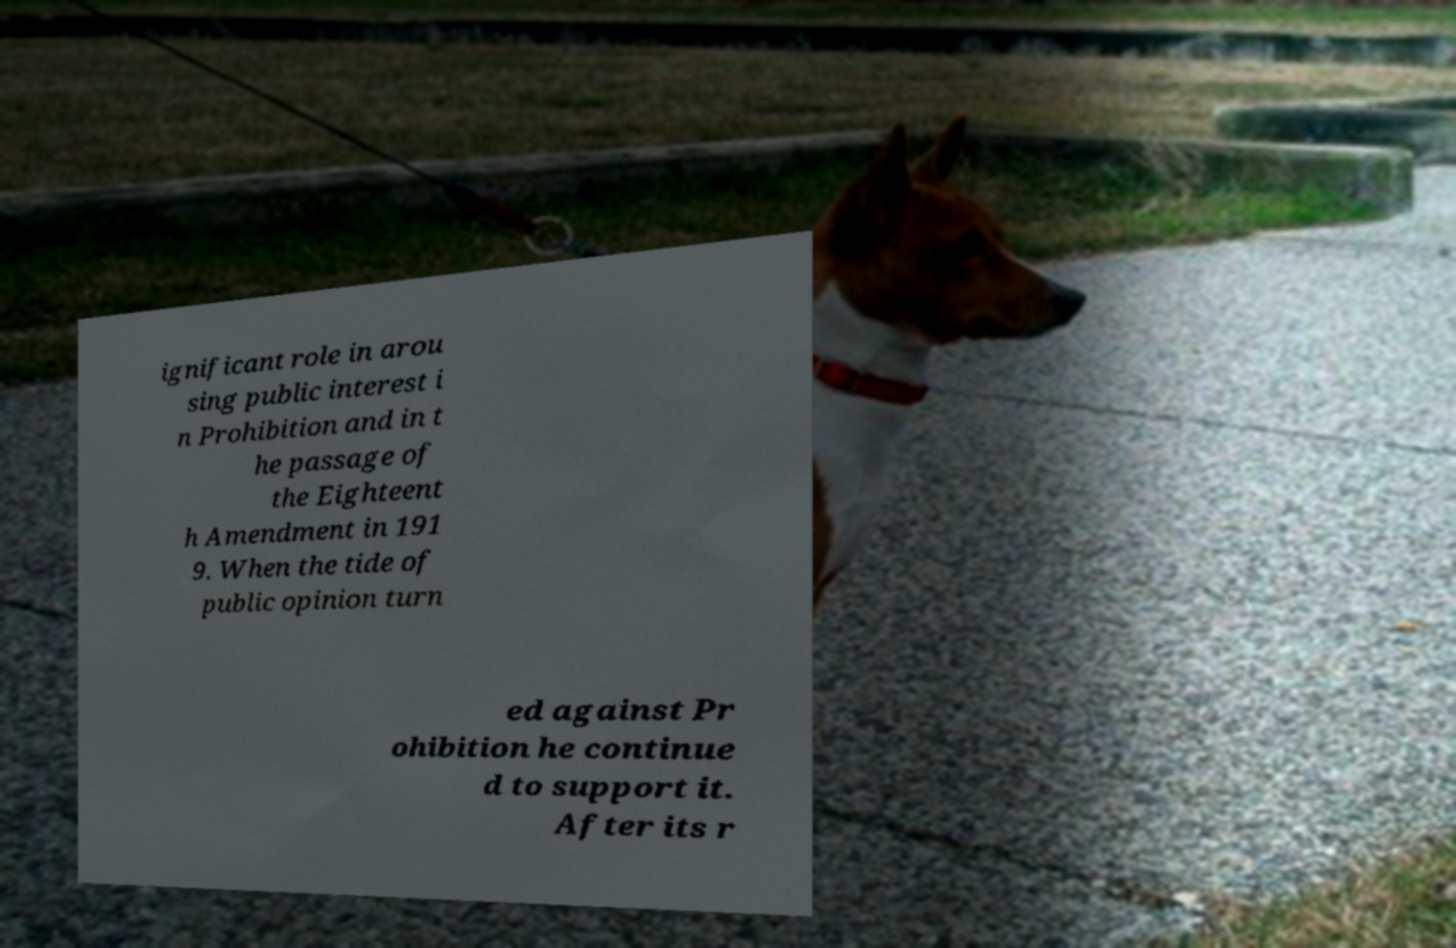Please read and relay the text visible in this image. What does it say? ignificant role in arou sing public interest i n Prohibition and in t he passage of the Eighteent h Amendment in 191 9. When the tide of public opinion turn ed against Pr ohibition he continue d to support it. After its r 